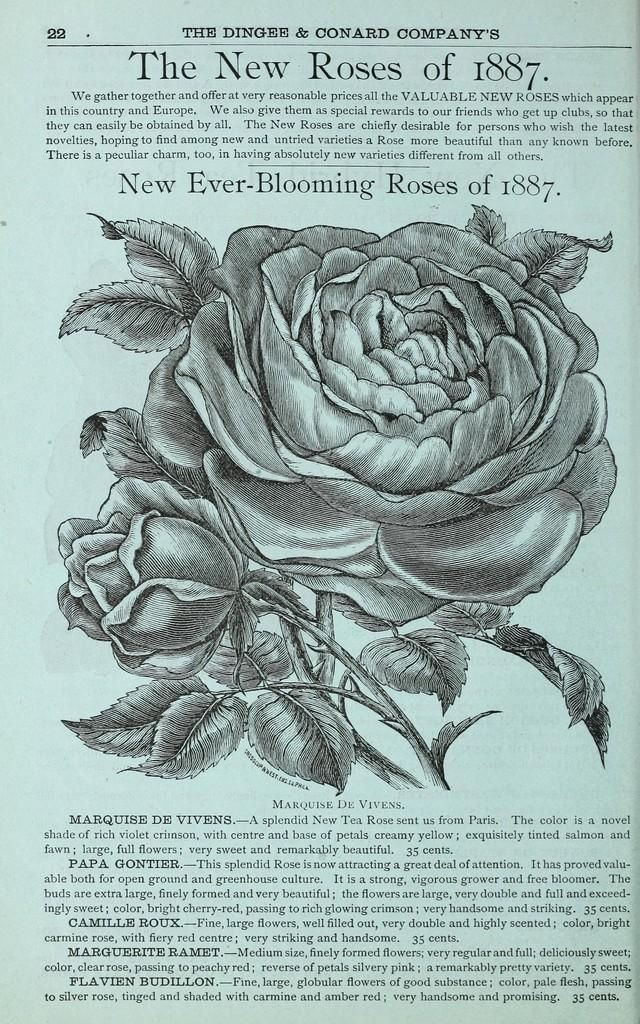What is depicted on the paper in the image? There is a drawing of a plant on a paper. What type of flowers does the plant in the drawing have? The plant in the drawing has rose flowers. Are there any words or phrases on the paper? Yes, there are texts above and below the drawing on the paper. What type of stem can be seen in the space depicted in the image? There is no space or stem present in the image; it features a drawing of a plant with rose flowers and text on a paper. 